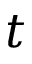<formula> <loc_0><loc_0><loc_500><loc_500>t</formula> 